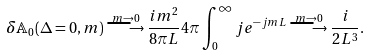<formula> <loc_0><loc_0><loc_500><loc_500>\delta { \mathbb { A } } _ { 0 } ( \Delta = 0 , m ) \stackrel { m \to 0 } { \longrightarrow } \frac { i m ^ { 2 } } { 8 \pi L } 4 \pi \int _ { 0 } ^ { \infty } j e ^ { - j m L } \stackrel { m \to 0 } { \longrightarrow } \frac { i } { 2 L ^ { 3 } } .</formula> 